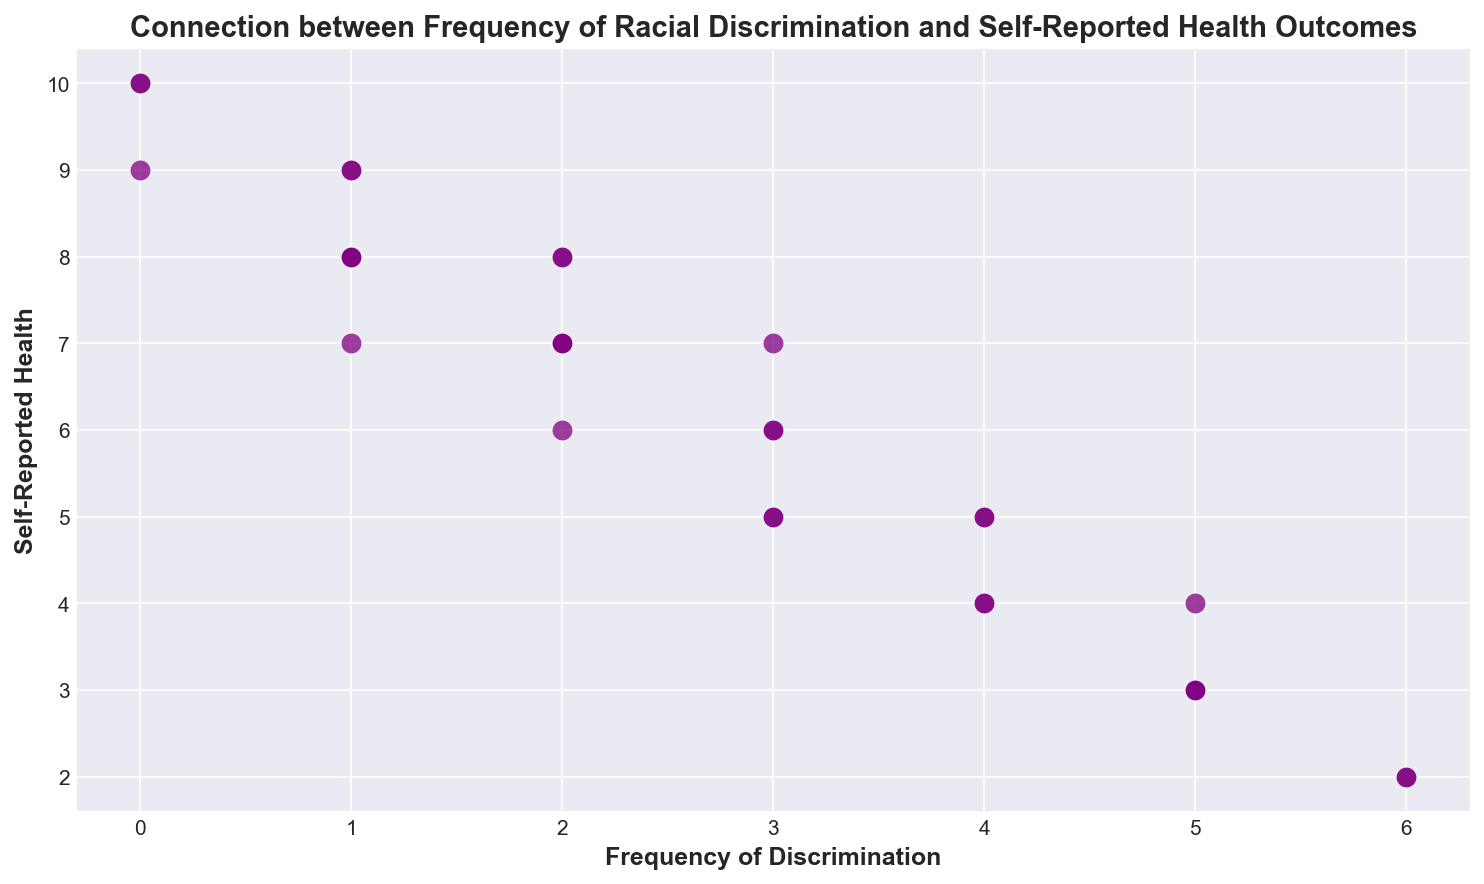What is the range of self-reported health values? To find the range, observe the minimum and maximum values on the y-axis. The lowest y-value is 2 and the highest y-value is 10, so the range is 10 - 2 = 8.
Answer: 8 What is the most frequent self-reported health outcome for those experiencing the highest frequency of discrimination? When the frequency of discrimination is highest (value 6), the self-reported health outcomes are 2. Therefore, 2 is the most frequent self-reported health outcome in this category.
Answer: 2 How does the average self-reported health outcome for discrimination frequency of 5 compare to frequency of 0? Calculate the average for both categories. For 5: (3 + 3 + 4 + 3)/4 = 3.25. For 0: (10 + 10 + 9)/3 = 9.67. Comparing them, the average for frequency 0 (9.67) is significantly higher than for frequency 5 (3.25).
Answer: 9.67 is higher than 3.25 Are there any instances where people reported a self-reported health of 10? If so, what is the level of discrimination for those instances? Observe the y-axis for the points at 10. There are two points at y = 10, both have a frequency of discrimination of 0.
Answer: Frequency = 0 What is the median value of self-reported health for all data points? Order all self-reported health values and find the middle value. The sorted values are [2, 2, 3, 3, 3, 4, 4, 4, 5, 5, 5, 5, 6, 6, 6, 7, 7, 7, 8, 8, 8, 8, 8, 9, 9, 9, 9, 10, 10, 10]. With 30 values, median is the average of 15th and 16th values: (6 + 7)/2 = 6.5.
Answer: 6.5 What trend, if any, can be observed between the frequency of discrimination and self-reported health outcomes? Notice the general pattern of the points. As the frequency of discrimination increases from 0 to 6, self-reported health outcomes seem to decrease, showing an inverse relationship.
Answer: Inverse relationship Are there any unique visual patterns, such as clusters or outliers, in the scatter plot? Looking at the scatter plot, there's a cluster of points around low discrimination frequency (0-2) with higher health values (7-10), while higher discrimination frequencies (4-6) cluster around lower health values (2-6). No distinct outliers are present.
Answer: Clusters: Higher health values for low discrimination; Lower health values for high discrimination 